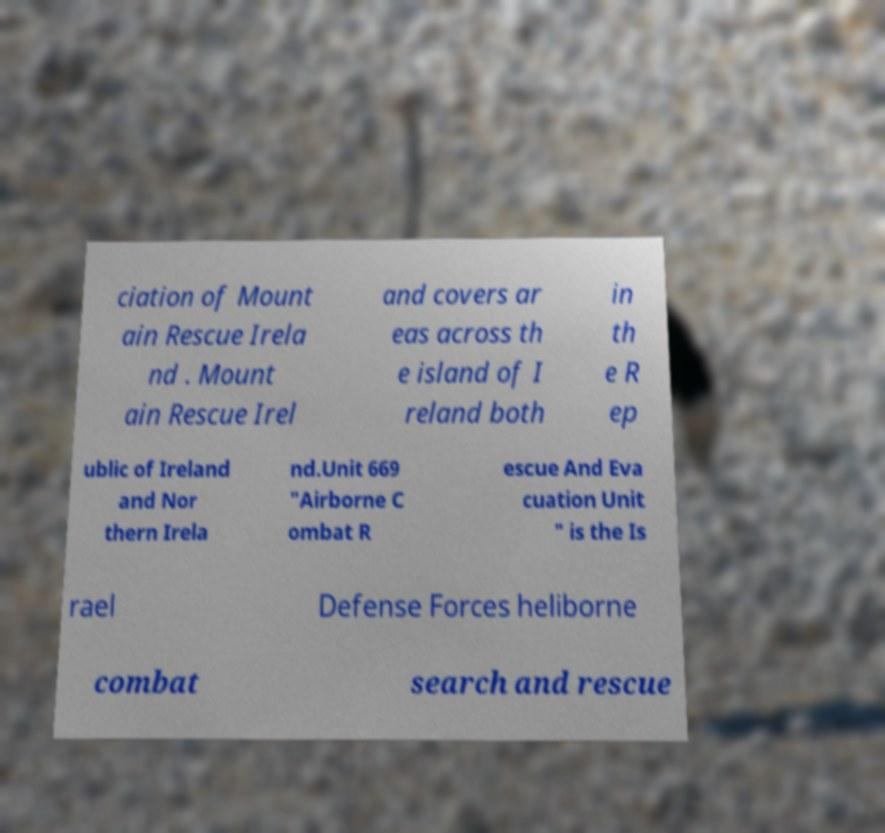Could you assist in decoding the text presented in this image and type it out clearly? ciation of Mount ain Rescue Irela nd . Mount ain Rescue Irel and covers ar eas across th e island of I reland both in th e R ep ublic of Ireland and Nor thern Irela nd.Unit 669 "Airborne C ombat R escue And Eva cuation Unit " is the Is rael Defense Forces heliborne combat search and rescue 